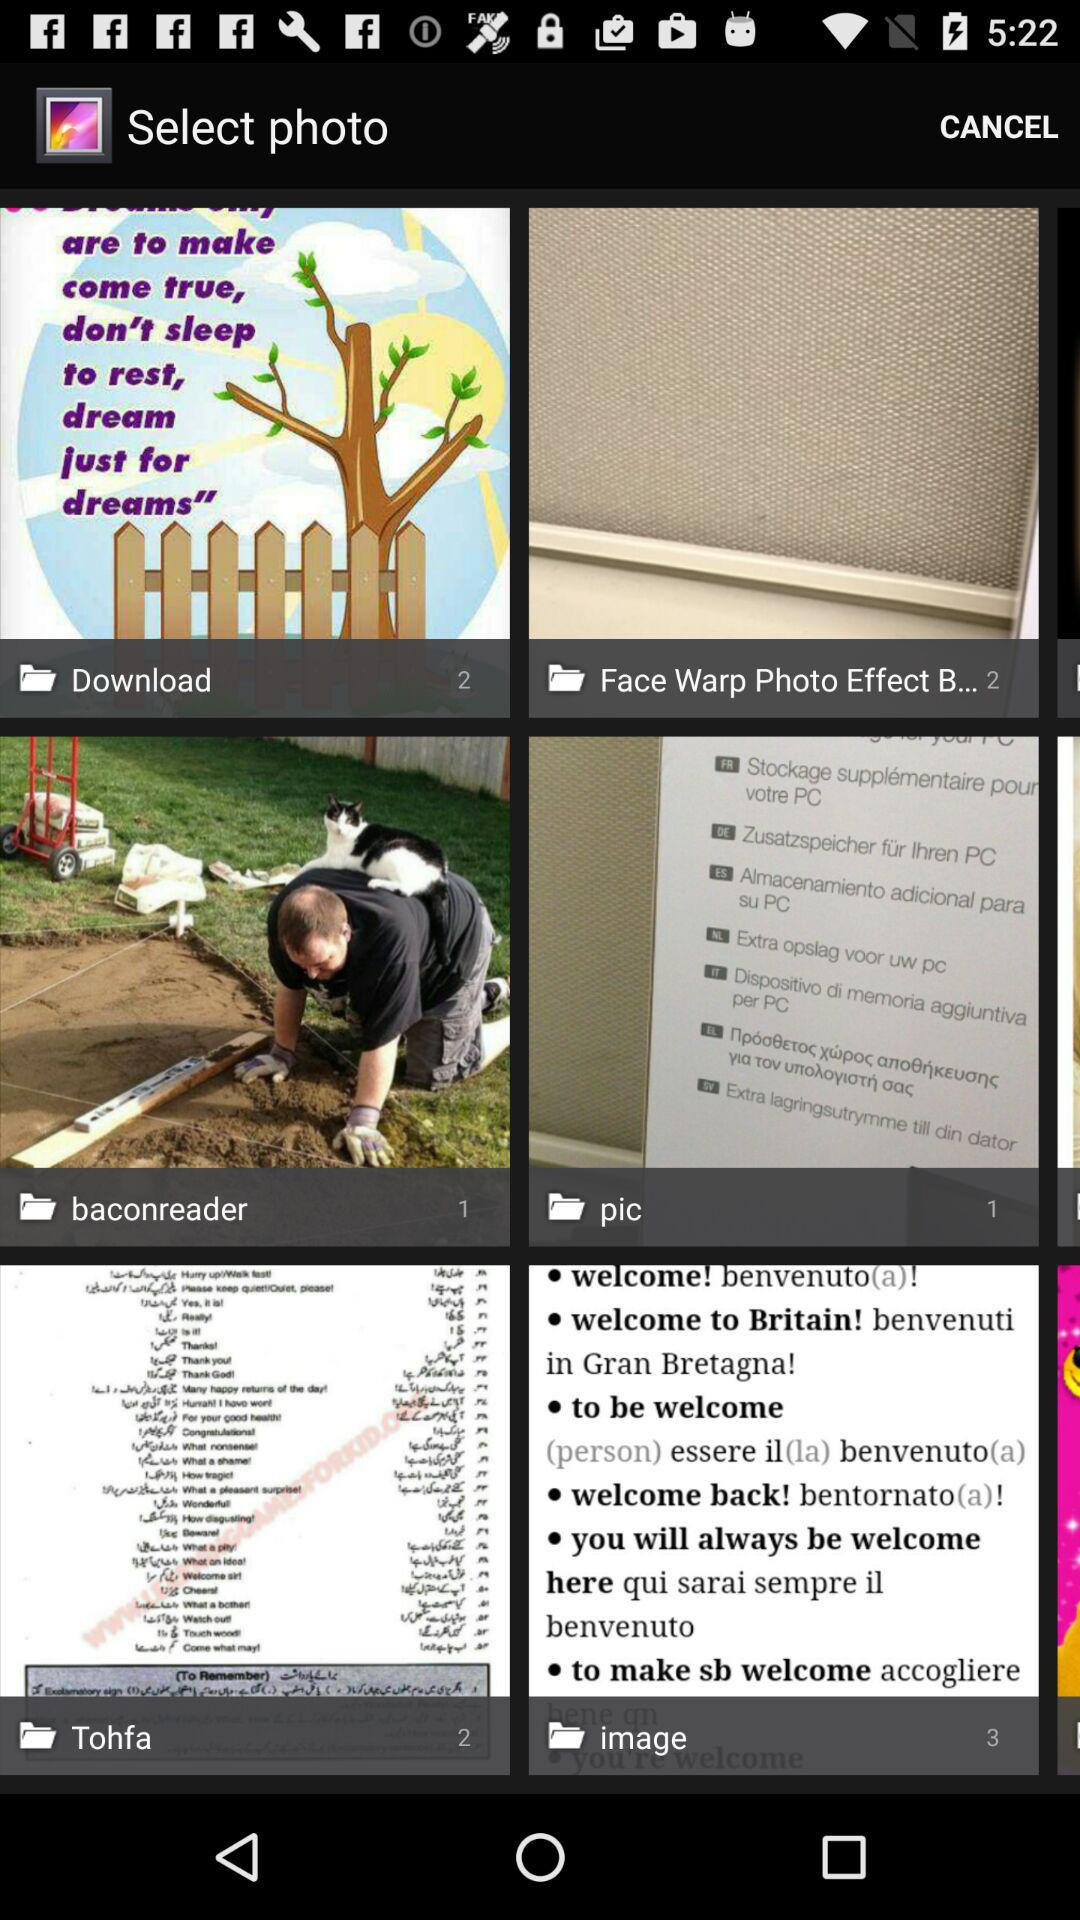How many photos are present in the "baconreader"? There is 1 photo present in the "baconreader". 